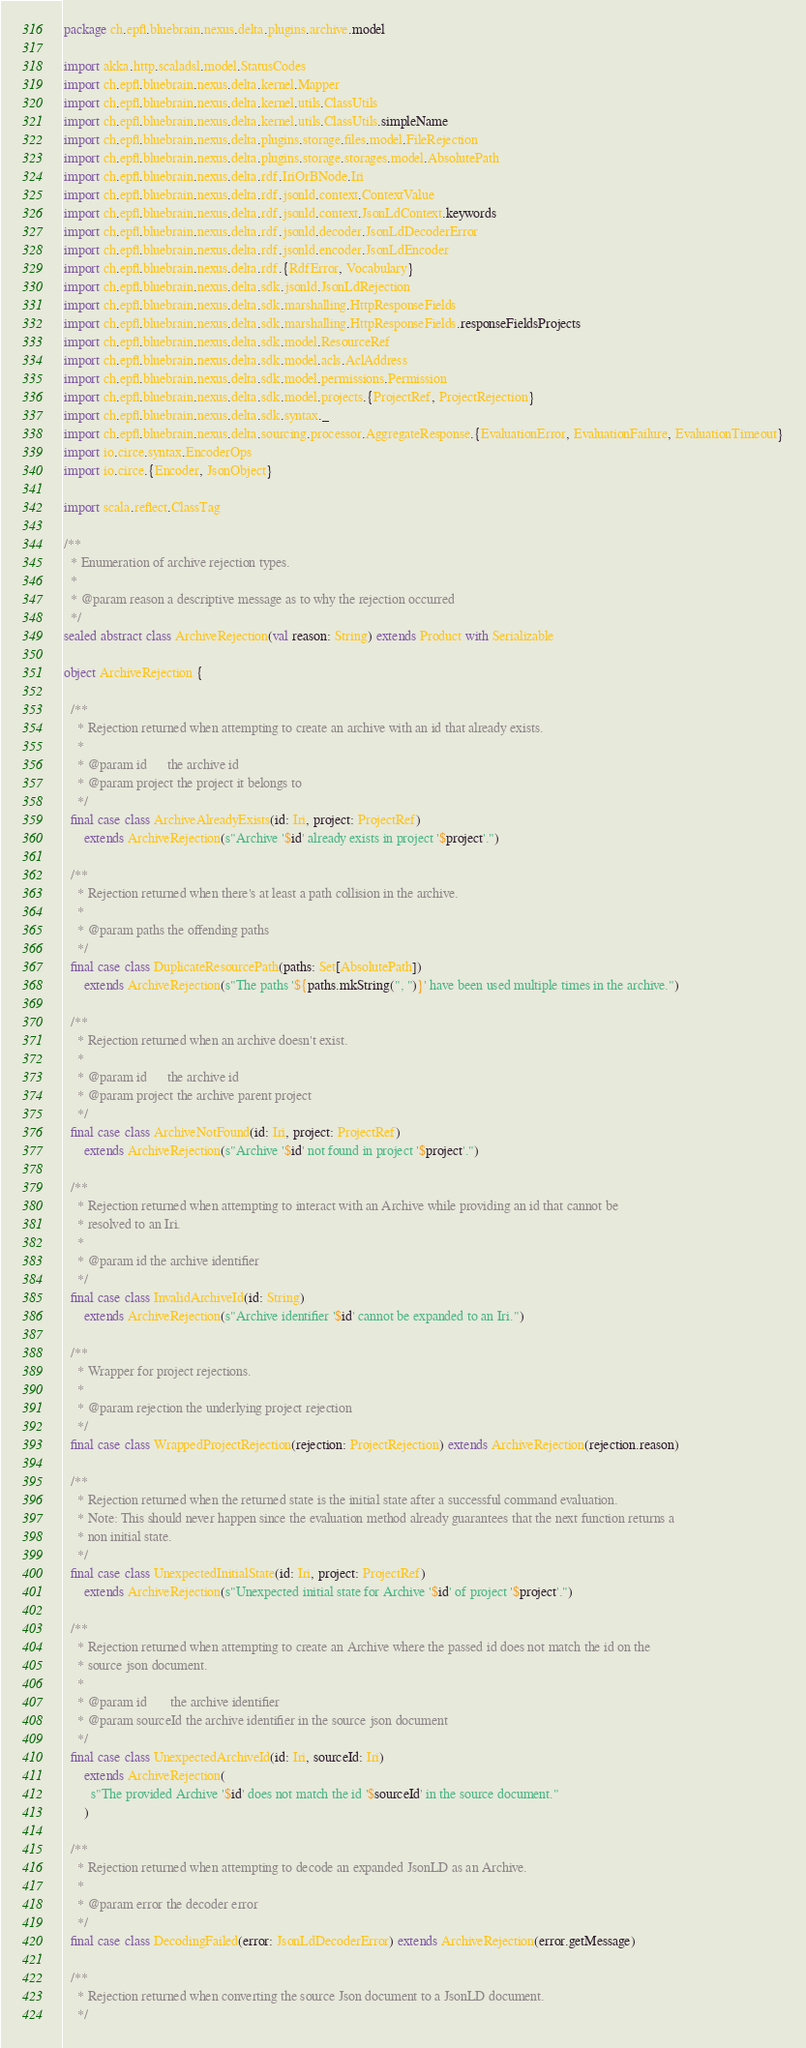Convert code to text. <code><loc_0><loc_0><loc_500><loc_500><_Scala_>package ch.epfl.bluebrain.nexus.delta.plugins.archive.model

import akka.http.scaladsl.model.StatusCodes
import ch.epfl.bluebrain.nexus.delta.kernel.Mapper
import ch.epfl.bluebrain.nexus.delta.kernel.utils.ClassUtils
import ch.epfl.bluebrain.nexus.delta.kernel.utils.ClassUtils.simpleName
import ch.epfl.bluebrain.nexus.delta.plugins.storage.files.model.FileRejection
import ch.epfl.bluebrain.nexus.delta.plugins.storage.storages.model.AbsolutePath
import ch.epfl.bluebrain.nexus.delta.rdf.IriOrBNode.Iri
import ch.epfl.bluebrain.nexus.delta.rdf.jsonld.context.ContextValue
import ch.epfl.bluebrain.nexus.delta.rdf.jsonld.context.JsonLdContext.keywords
import ch.epfl.bluebrain.nexus.delta.rdf.jsonld.decoder.JsonLdDecoderError
import ch.epfl.bluebrain.nexus.delta.rdf.jsonld.encoder.JsonLdEncoder
import ch.epfl.bluebrain.nexus.delta.rdf.{RdfError, Vocabulary}
import ch.epfl.bluebrain.nexus.delta.sdk.jsonld.JsonLdRejection
import ch.epfl.bluebrain.nexus.delta.sdk.marshalling.HttpResponseFields
import ch.epfl.bluebrain.nexus.delta.sdk.marshalling.HttpResponseFields.responseFieldsProjects
import ch.epfl.bluebrain.nexus.delta.sdk.model.ResourceRef
import ch.epfl.bluebrain.nexus.delta.sdk.model.acls.AclAddress
import ch.epfl.bluebrain.nexus.delta.sdk.model.permissions.Permission
import ch.epfl.bluebrain.nexus.delta.sdk.model.projects.{ProjectRef, ProjectRejection}
import ch.epfl.bluebrain.nexus.delta.sdk.syntax._
import ch.epfl.bluebrain.nexus.delta.sourcing.processor.AggregateResponse.{EvaluationError, EvaluationFailure, EvaluationTimeout}
import io.circe.syntax.EncoderOps
import io.circe.{Encoder, JsonObject}

import scala.reflect.ClassTag

/**
  * Enumeration of archive rejection types.
  *
  * @param reason a descriptive message as to why the rejection occurred
  */
sealed abstract class ArchiveRejection(val reason: String) extends Product with Serializable

object ArchiveRejection {

  /**
    * Rejection returned when attempting to create an archive with an id that already exists.
    *
    * @param id      the archive id
    * @param project the project it belongs to
    */
  final case class ArchiveAlreadyExists(id: Iri, project: ProjectRef)
      extends ArchiveRejection(s"Archive '$id' already exists in project '$project'.")

  /**
    * Rejection returned when there's at least a path collision in the archive.
    *
    * @param paths the offending paths
    */
  final case class DuplicateResourcePath(paths: Set[AbsolutePath])
      extends ArchiveRejection(s"The paths '${paths.mkString(", ")}' have been used multiple times in the archive.")

  /**
    * Rejection returned when an archive doesn't exist.
    *
    * @param id      the archive id
    * @param project the archive parent project
    */
  final case class ArchiveNotFound(id: Iri, project: ProjectRef)
      extends ArchiveRejection(s"Archive '$id' not found in project '$project'.")

  /**
    * Rejection returned when attempting to interact with an Archive while providing an id that cannot be
    * resolved to an Iri.
    *
    * @param id the archive identifier
    */
  final case class InvalidArchiveId(id: String)
      extends ArchiveRejection(s"Archive identifier '$id' cannot be expanded to an Iri.")

  /**
    * Wrapper for project rejections.
    *
    * @param rejection the underlying project rejection
    */
  final case class WrappedProjectRejection(rejection: ProjectRejection) extends ArchiveRejection(rejection.reason)

  /**
    * Rejection returned when the returned state is the initial state after a successful command evaluation.
    * Note: This should never happen since the evaluation method already guarantees that the next function returns a
    * non initial state.
    */
  final case class UnexpectedInitialState(id: Iri, project: ProjectRef)
      extends ArchiveRejection(s"Unexpected initial state for Archive '$id' of project '$project'.")

  /**
    * Rejection returned when attempting to create an Archive where the passed id does not match the id on the
    * source json document.
    *
    * @param id       the archive identifier
    * @param sourceId the archive identifier in the source json document
    */
  final case class UnexpectedArchiveId(id: Iri, sourceId: Iri)
      extends ArchiveRejection(
        s"The provided Archive '$id' does not match the id '$sourceId' in the source document."
      )

  /**
    * Rejection returned when attempting to decode an expanded JsonLD as an Archive.
    *
    * @param error the decoder error
    */
  final case class DecodingFailed(error: JsonLdDecoderError) extends ArchiveRejection(error.getMessage)

  /**
    * Rejection returned when converting the source Json document to a JsonLD document.
    */</code> 